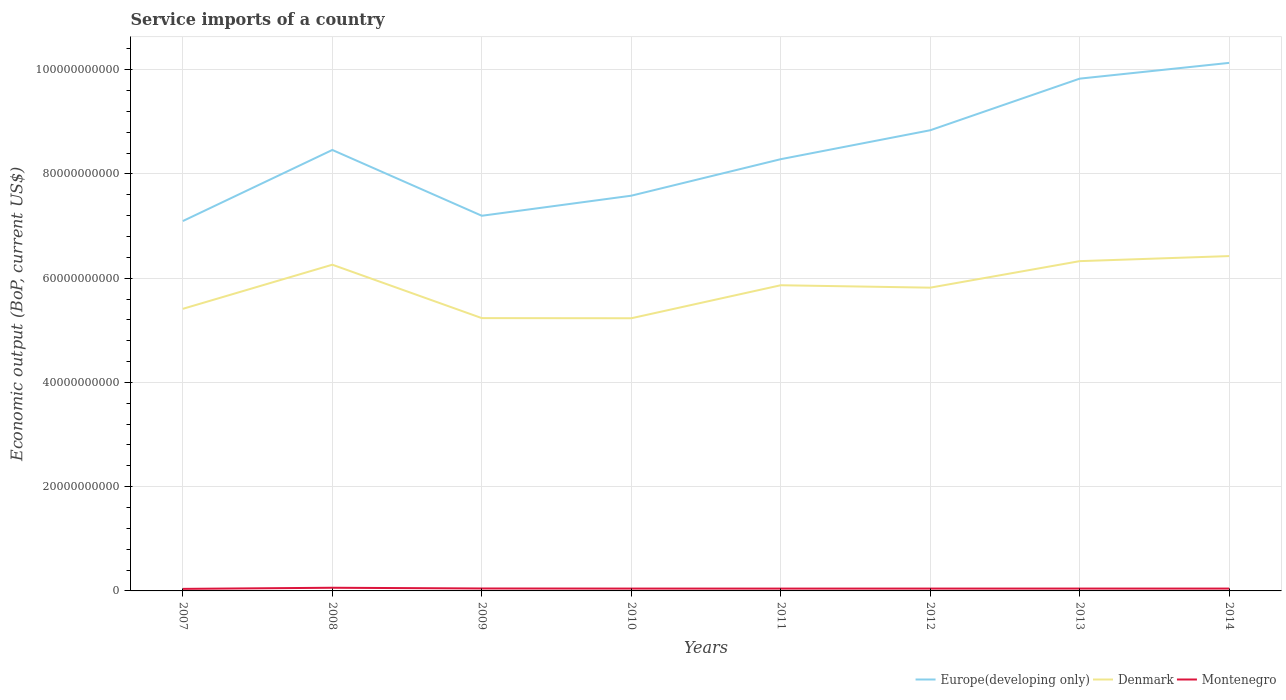How many different coloured lines are there?
Your answer should be very brief. 3. Across all years, what is the maximum service imports in Denmark?
Your answer should be very brief. 5.23e+1. What is the total service imports in Europe(developing only) in the graph?
Ensure brevity in your answer.  -1.19e+1. What is the difference between the highest and the second highest service imports in Montenegro?
Provide a short and direct response. 2.15e+08. What is the difference between the highest and the lowest service imports in Denmark?
Keep it short and to the point. 4. Are the values on the major ticks of Y-axis written in scientific E-notation?
Provide a succinct answer. No. Where does the legend appear in the graph?
Ensure brevity in your answer.  Bottom right. How many legend labels are there?
Keep it short and to the point. 3. How are the legend labels stacked?
Your answer should be very brief. Horizontal. What is the title of the graph?
Your response must be concise. Service imports of a country. What is the label or title of the X-axis?
Give a very brief answer. Years. What is the label or title of the Y-axis?
Ensure brevity in your answer.  Economic output (BoP, current US$). What is the Economic output (BoP, current US$) in Europe(developing only) in 2007?
Your answer should be very brief. 7.10e+1. What is the Economic output (BoP, current US$) in Denmark in 2007?
Make the answer very short. 5.41e+1. What is the Economic output (BoP, current US$) in Montenegro in 2007?
Offer a very short reply. 3.94e+08. What is the Economic output (BoP, current US$) in Europe(developing only) in 2008?
Give a very brief answer. 8.46e+1. What is the Economic output (BoP, current US$) of Denmark in 2008?
Your answer should be very brief. 6.26e+1. What is the Economic output (BoP, current US$) of Montenegro in 2008?
Keep it short and to the point. 6.09e+08. What is the Economic output (BoP, current US$) of Europe(developing only) in 2009?
Your answer should be compact. 7.20e+1. What is the Economic output (BoP, current US$) in Denmark in 2009?
Keep it short and to the point. 5.23e+1. What is the Economic output (BoP, current US$) of Montenegro in 2009?
Provide a short and direct response. 4.67e+08. What is the Economic output (BoP, current US$) in Europe(developing only) in 2010?
Offer a terse response. 7.58e+1. What is the Economic output (BoP, current US$) in Denmark in 2010?
Your response must be concise. 5.23e+1. What is the Economic output (BoP, current US$) of Montenegro in 2010?
Your answer should be compact. 4.51e+08. What is the Economic output (BoP, current US$) in Europe(developing only) in 2011?
Provide a short and direct response. 8.28e+1. What is the Economic output (BoP, current US$) in Denmark in 2011?
Provide a succinct answer. 5.86e+1. What is the Economic output (BoP, current US$) in Montenegro in 2011?
Ensure brevity in your answer.  4.48e+08. What is the Economic output (BoP, current US$) of Europe(developing only) in 2012?
Your response must be concise. 8.84e+1. What is the Economic output (BoP, current US$) in Denmark in 2012?
Your response must be concise. 5.82e+1. What is the Economic output (BoP, current US$) in Montenegro in 2012?
Ensure brevity in your answer.  4.49e+08. What is the Economic output (BoP, current US$) in Europe(developing only) in 2013?
Make the answer very short. 9.83e+1. What is the Economic output (BoP, current US$) in Denmark in 2013?
Keep it short and to the point. 6.33e+1. What is the Economic output (BoP, current US$) in Montenegro in 2013?
Make the answer very short. 4.53e+08. What is the Economic output (BoP, current US$) of Europe(developing only) in 2014?
Give a very brief answer. 1.01e+11. What is the Economic output (BoP, current US$) of Denmark in 2014?
Offer a very short reply. 6.42e+1. What is the Economic output (BoP, current US$) in Montenegro in 2014?
Offer a very short reply. 4.51e+08. Across all years, what is the maximum Economic output (BoP, current US$) of Europe(developing only)?
Keep it short and to the point. 1.01e+11. Across all years, what is the maximum Economic output (BoP, current US$) of Denmark?
Offer a terse response. 6.42e+1. Across all years, what is the maximum Economic output (BoP, current US$) of Montenegro?
Provide a succinct answer. 6.09e+08. Across all years, what is the minimum Economic output (BoP, current US$) of Europe(developing only)?
Your answer should be very brief. 7.10e+1. Across all years, what is the minimum Economic output (BoP, current US$) in Denmark?
Your response must be concise. 5.23e+1. Across all years, what is the minimum Economic output (BoP, current US$) in Montenegro?
Provide a succinct answer. 3.94e+08. What is the total Economic output (BoP, current US$) of Europe(developing only) in the graph?
Offer a very short reply. 6.74e+11. What is the total Economic output (BoP, current US$) of Denmark in the graph?
Offer a terse response. 4.66e+11. What is the total Economic output (BoP, current US$) of Montenegro in the graph?
Provide a succinct answer. 3.72e+09. What is the difference between the Economic output (BoP, current US$) in Europe(developing only) in 2007 and that in 2008?
Make the answer very short. -1.36e+1. What is the difference between the Economic output (BoP, current US$) in Denmark in 2007 and that in 2008?
Ensure brevity in your answer.  -8.46e+09. What is the difference between the Economic output (BoP, current US$) in Montenegro in 2007 and that in 2008?
Give a very brief answer. -2.15e+08. What is the difference between the Economic output (BoP, current US$) in Europe(developing only) in 2007 and that in 2009?
Give a very brief answer. -1.01e+09. What is the difference between the Economic output (BoP, current US$) in Denmark in 2007 and that in 2009?
Ensure brevity in your answer.  1.78e+09. What is the difference between the Economic output (BoP, current US$) in Montenegro in 2007 and that in 2009?
Provide a short and direct response. -7.32e+07. What is the difference between the Economic output (BoP, current US$) in Europe(developing only) in 2007 and that in 2010?
Provide a succinct answer. -4.86e+09. What is the difference between the Economic output (BoP, current US$) of Denmark in 2007 and that in 2010?
Your answer should be compact. 1.81e+09. What is the difference between the Economic output (BoP, current US$) of Montenegro in 2007 and that in 2010?
Offer a very short reply. -5.69e+07. What is the difference between the Economic output (BoP, current US$) in Europe(developing only) in 2007 and that in 2011?
Make the answer very short. -1.19e+1. What is the difference between the Economic output (BoP, current US$) in Denmark in 2007 and that in 2011?
Give a very brief answer. -4.52e+09. What is the difference between the Economic output (BoP, current US$) of Montenegro in 2007 and that in 2011?
Ensure brevity in your answer.  -5.38e+07. What is the difference between the Economic output (BoP, current US$) in Europe(developing only) in 2007 and that in 2012?
Keep it short and to the point. -1.74e+1. What is the difference between the Economic output (BoP, current US$) of Denmark in 2007 and that in 2012?
Your answer should be very brief. -4.06e+09. What is the difference between the Economic output (BoP, current US$) in Montenegro in 2007 and that in 2012?
Offer a terse response. -5.52e+07. What is the difference between the Economic output (BoP, current US$) in Europe(developing only) in 2007 and that in 2013?
Your answer should be compact. -2.73e+1. What is the difference between the Economic output (BoP, current US$) in Denmark in 2007 and that in 2013?
Give a very brief answer. -9.15e+09. What is the difference between the Economic output (BoP, current US$) of Montenegro in 2007 and that in 2013?
Your response must be concise. -5.95e+07. What is the difference between the Economic output (BoP, current US$) of Europe(developing only) in 2007 and that in 2014?
Offer a terse response. -3.03e+1. What is the difference between the Economic output (BoP, current US$) in Denmark in 2007 and that in 2014?
Offer a very short reply. -1.01e+1. What is the difference between the Economic output (BoP, current US$) of Montenegro in 2007 and that in 2014?
Your answer should be compact. -5.68e+07. What is the difference between the Economic output (BoP, current US$) in Europe(developing only) in 2008 and that in 2009?
Provide a succinct answer. 1.26e+1. What is the difference between the Economic output (BoP, current US$) in Denmark in 2008 and that in 2009?
Make the answer very short. 1.02e+1. What is the difference between the Economic output (BoP, current US$) of Montenegro in 2008 and that in 2009?
Your response must be concise. 1.42e+08. What is the difference between the Economic output (BoP, current US$) in Europe(developing only) in 2008 and that in 2010?
Ensure brevity in your answer.  8.77e+09. What is the difference between the Economic output (BoP, current US$) in Denmark in 2008 and that in 2010?
Give a very brief answer. 1.03e+1. What is the difference between the Economic output (BoP, current US$) in Montenegro in 2008 and that in 2010?
Your answer should be compact. 1.58e+08. What is the difference between the Economic output (BoP, current US$) of Europe(developing only) in 2008 and that in 2011?
Give a very brief answer. 1.77e+09. What is the difference between the Economic output (BoP, current US$) in Denmark in 2008 and that in 2011?
Make the answer very short. 3.94e+09. What is the difference between the Economic output (BoP, current US$) in Montenegro in 2008 and that in 2011?
Offer a very short reply. 1.61e+08. What is the difference between the Economic output (BoP, current US$) of Europe(developing only) in 2008 and that in 2012?
Keep it short and to the point. -3.78e+09. What is the difference between the Economic output (BoP, current US$) of Denmark in 2008 and that in 2012?
Give a very brief answer. 4.40e+09. What is the difference between the Economic output (BoP, current US$) in Montenegro in 2008 and that in 2012?
Ensure brevity in your answer.  1.60e+08. What is the difference between the Economic output (BoP, current US$) in Europe(developing only) in 2008 and that in 2013?
Your response must be concise. -1.37e+1. What is the difference between the Economic output (BoP, current US$) of Denmark in 2008 and that in 2013?
Provide a succinct answer. -6.86e+08. What is the difference between the Economic output (BoP, current US$) in Montenegro in 2008 and that in 2013?
Offer a terse response. 1.56e+08. What is the difference between the Economic output (BoP, current US$) of Europe(developing only) in 2008 and that in 2014?
Give a very brief answer. -1.67e+1. What is the difference between the Economic output (BoP, current US$) in Denmark in 2008 and that in 2014?
Make the answer very short. -1.66e+09. What is the difference between the Economic output (BoP, current US$) of Montenegro in 2008 and that in 2014?
Ensure brevity in your answer.  1.58e+08. What is the difference between the Economic output (BoP, current US$) of Europe(developing only) in 2009 and that in 2010?
Your response must be concise. -3.85e+09. What is the difference between the Economic output (BoP, current US$) in Denmark in 2009 and that in 2010?
Your answer should be compact. 2.79e+07. What is the difference between the Economic output (BoP, current US$) in Montenegro in 2009 and that in 2010?
Provide a short and direct response. 1.63e+07. What is the difference between the Economic output (BoP, current US$) of Europe(developing only) in 2009 and that in 2011?
Your answer should be compact. -1.09e+1. What is the difference between the Economic output (BoP, current US$) of Denmark in 2009 and that in 2011?
Make the answer very short. -6.30e+09. What is the difference between the Economic output (BoP, current US$) in Montenegro in 2009 and that in 2011?
Your answer should be compact. 1.94e+07. What is the difference between the Economic output (BoP, current US$) in Europe(developing only) in 2009 and that in 2012?
Your answer should be very brief. -1.64e+1. What is the difference between the Economic output (BoP, current US$) of Denmark in 2009 and that in 2012?
Offer a terse response. -5.84e+09. What is the difference between the Economic output (BoP, current US$) in Montenegro in 2009 and that in 2012?
Your answer should be compact. 1.80e+07. What is the difference between the Economic output (BoP, current US$) in Europe(developing only) in 2009 and that in 2013?
Your answer should be compact. -2.63e+1. What is the difference between the Economic output (BoP, current US$) in Denmark in 2009 and that in 2013?
Your answer should be compact. -1.09e+1. What is the difference between the Economic output (BoP, current US$) in Montenegro in 2009 and that in 2013?
Your answer should be compact. 1.38e+07. What is the difference between the Economic output (BoP, current US$) of Europe(developing only) in 2009 and that in 2014?
Make the answer very short. -2.93e+1. What is the difference between the Economic output (BoP, current US$) of Denmark in 2009 and that in 2014?
Make the answer very short. -1.19e+1. What is the difference between the Economic output (BoP, current US$) in Montenegro in 2009 and that in 2014?
Your answer should be compact. 1.64e+07. What is the difference between the Economic output (BoP, current US$) in Europe(developing only) in 2010 and that in 2011?
Give a very brief answer. -7.00e+09. What is the difference between the Economic output (BoP, current US$) in Denmark in 2010 and that in 2011?
Provide a succinct answer. -6.33e+09. What is the difference between the Economic output (BoP, current US$) of Montenegro in 2010 and that in 2011?
Your response must be concise. 3.09e+06. What is the difference between the Economic output (BoP, current US$) in Europe(developing only) in 2010 and that in 2012?
Provide a short and direct response. -1.26e+1. What is the difference between the Economic output (BoP, current US$) of Denmark in 2010 and that in 2012?
Give a very brief answer. -5.87e+09. What is the difference between the Economic output (BoP, current US$) of Montenegro in 2010 and that in 2012?
Keep it short and to the point. 1.73e+06. What is the difference between the Economic output (BoP, current US$) of Europe(developing only) in 2010 and that in 2013?
Provide a short and direct response. -2.25e+1. What is the difference between the Economic output (BoP, current US$) in Denmark in 2010 and that in 2013?
Offer a very short reply. -1.10e+1. What is the difference between the Economic output (BoP, current US$) of Montenegro in 2010 and that in 2013?
Give a very brief answer. -2.53e+06. What is the difference between the Economic output (BoP, current US$) of Europe(developing only) in 2010 and that in 2014?
Offer a very short reply. -2.55e+1. What is the difference between the Economic output (BoP, current US$) of Denmark in 2010 and that in 2014?
Give a very brief answer. -1.19e+1. What is the difference between the Economic output (BoP, current US$) of Montenegro in 2010 and that in 2014?
Give a very brief answer. 1.15e+05. What is the difference between the Economic output (BoP, current US$) of Europe(developing only) in 2011 and that in 2012?
Provide a short and direct response. -5.55e+09. What is the difference between the Economic output (BoP, current US$) of Denmark in 2011 and that in 2012?
Ensure brevity in your answer.  4.63e+08. What is the difference between the Economic output (BoP, current US$) in Montenegro in 2011 and that in 2012?
Offer a terse response. -1.36e+06. What is the difference between the Economic output (BoP, current US$) of Europe(developing only) in 2011 and that in 2013?
Offer a very short reply. -1.55e+1. What is the difference between the Economic output (BoP, current US$) of Denmark in 2011 and that in 2013?
Your answer should be very brief. -4.63e+09. What is the difference between the Economic output (BoP, current US$) in Montenegro in 2011 and that in 2013?
Keep it short and to the point. -5.62e+06. What is the difference between the Economic output (BoP, current US$) in Europe(developing only) in 2011 and that in 2014?
Provide a succinct answer. -1.85e+1. What is the difference between the Economic output (BoP, current US$) in Denmark in 2011 and that in 2014?
Offer a terse response. -5.60e+09. What is the difference between the Economic output (BoP, current US$) in Montenegro in 2011 and that in 2014?
Your answer should be very brief. -2.97e+06. What is the difference between the Economic output (BoP, current US$) in Europe(developing only) in 2012 and that in 2013?
Provide a short and direct response. -9.90e+09. What is the difference between the Economic output (BoP, current US$) in Denmark in 2012 and that in 2013?
Give a very brief answer. -5.09e+09. What is the difference between the Economic output (BoP, current US$) in Montenegro in 2012 and that in 2013?
Give a very brief answer. -4.26e+06. What is the difference between the Economic output (BoP, current US$) of Europe(developing only) in 2012 and that in 2014?
Provide a succinct answer. -1.29e+1. What is the difference between the Economic output (BoP, current US$) of Denmark in 2012 and that in 2014?
Make the answer very short. -6.06e+09. What is the difference between the Economic output (BoP, current US$) of Montenegro in 2012 and that in 2014?
Provide a succinct answer. -1.61e+06. What is the difference between the Economic output (BoP, current US$) of Europe(developing only) in 2013 and that in 2014?
Offer a terse response. -3.02e+09. What is the difference between the Economic output (BoP, current US$) of Denmark in 2013 and that in 2014?
Your answer should be very brief. -9.70e+08. What is the difference between the Economic output (BoP, current US$) of Montenegro in 2013 and that in 2014?
Provide a short and direct response. 2.65e+06. What is the difference between the Economic output (BoP, current US$) in Europe(developing only) in 2007 and the Economic output (BoP, current US$) in Denmark in 2008?
Offer a very short reply. 8.38e+09. What is the difference between the Economic output (BoP, current US$) in Europe(developing only) in 2007 and the Economic output (BoP, current US$) in Montenegro in 2008?
Make the answer very short. 7.04e+1. What is the difference between the Economic output (BoP, current US$) of Denmark in 2007 and the Economic output (BoP, current US$) of Montenegro in 2008?
Your response must be concise. 5.35e+1. What is the difference between the Economic output (BoP, current US$) of Europe(developing only) in 2007 and the Economic output (BoP, current US$) of Denmark in 2009?
Offer a terse response. 1.86e+1. What is the difference between the Economic output (BoP, current US$) in Europe(developing only) in 2007 and the Economic output (BoP, current US$) in Montenegro in 2009?
Ensure brevity in your answer.  7.05e+1. What is the difference between the Economic output (BoP, current US$) of Denmark in 2007 and the Economic output (BoP, current US$) of Montenegro in 2009?
Offer a very short reply. 5.37e+1. What is the difference between the Economic output (BoP, current US$) in Europe(developing only) in 2007 and the Economic output (BoP, current US$) in Denmark in 2010?
Your answer should be compact. 1.86e+1. What is the difference between the Economic output (BoP, current US$) in Europe(developing only) in 2007 and the Economic output (BoP, current US$) in Montenegro in 2010?
Make the answer very short. 7.05e+1. What is the difference between the Economic output (BoP, current US$) in Denmark in 2007 and the Economic output (BoP, current US$) in Montenegro in 2010?
Ensure brevity in your answer.  5.37e+1. What is the difference between the Economic output (BoP, current US$) of Europe(developing only) in 2007 and the Economic output (BoP, current US$) of Denmark in 2011?
Your answer should be compact. 1.23e+1. What is the difference between the Economic output (BoP, current US$) in Europe(developing only) in 2007 and the Economic output (BoP, current US$) in Montenegro in 2011?
Keep it short and to the point. 7.05e+1. What is the difference between the Economic output (BoP, current US$) in Denmark in 2007 and the Economic output (BoP, current US$) in Montenegro in 2011?
Keep it short and to the point. 5.37e+1. What is the difference between the Economic output (BoP, current US$) of Europe(developing only) in 2007 and the Economic output (BoP, current US$) of Denmark in 2012?
Provide a short and direct response. 1.28e+1. What is the difference between the Economic output (BoP, current US$) in Europe(developing only) in 2007 and the Economic output (BoP, current US$) in Montenegro in 2012?
Offer a terse response. 7.05e+1. What is the difference between the Economic output (BoP, current US$) in Denmark in 2007 and the Economic output (BoP, current US$) in Montenegro in 2012?
Offer a terse response. 5.37e+1. What is the difference between the Economic output (BoP, current US$) of Europe(developing only) in 2007 and the Economic output (BoP, current US$) of Denmark in 2013?
Provide a short and direct response. 7.69e+09. What is the difference between the Economic output (BoP, current US$) in Europe(developing only) in 2007 and the Economic output (BoP, current US$) in Montenegro in 2013?
Offer a very short reply. 7.05e+1. What is the difference between the Economic output (BoP, current US$) of Denmark in 2007 and the Economic output (BoP, current US$) of Montenegro in 2013?
Your answer should be very brief. 5.37e+1. What is the difference between the Economic output (BoP, current US$) of Europe(developing only) in 2007 and the Economic output (BoP, current US$) of Denmark in 2014?
Offer a terse response. 6.72e+09. What is the difference between the Economic output (BoP, current US$) of Europe(developing only) in 2007 and the Economic output (BoP, current US$) of Montenegro in 2014?
Your answer should be very brief. 7.05e+1. What is the difference between the Economic output (BoP, current US$) in Denmark in 2007 and the Economic output (BoP, current US$) in Montenegro in 2014?
Offer a terse response. 5.37e+1. What is the difference between the Economic output (BoP, current US$) of Europe(developing only) in 2008 and the Economic output (BoP, current US$) of Denmark in 2009?
Give a very brief answer. 3.23e+1. What is the difference between the Economic output (BoP, current US$) of Europe(developing only) in 2008 and the Economic output (BoP, current US$) of Montenegro in 2009?
Your answer should be compact. 8.41e+1. What is the difference between the Economic output (BoP, current US$) of Denmark in 2008 and the Economic output (BoP, current US$) of Montenegro in 2009?
Keep it short and to the point. 6.21e+1. What is the difference between the Economic output (BoP, current US$) of Europe(developing only) in 2008 and the Economic output (BoP, current US$) of Denmark in 2010?
Your response must be concise. 3.23e+1. What is the difference between the Economic output (BoP, current US$) of Europe(developing only) in 2008 and the Economic output (BoP, current US$) of Montenegro in 2010?
Provide a short and direct response. 8.41e+1. What is the difference between the Economic output (BoP, current US$) of Denmark in 2008 and the Economic output (BoP, current US$) of Montenegro in 2010?
Keep it short and to the point. 6.21e+1. What is the difference between the Economic output (BoP, current US$) in Europe(developing only) in 2008 and the Economic output (BoP, current US$) in Denmark in 2011?
Provide a succinct answer. 2.60e+1. What is the difference between the Economic output (BoP, current US$) in Europe(developing only) in 2008 and the Economic output (BoP, current US$) in Montenegro in 2011?
Provide a short and direct response. 8.42e+1. What is the difference between the Economic output (BoP, current US$) of Denmark in 2008 and the Economic output (BoP, current US$) of Montenegro in 2011?
Make the answer very short. 6.21e+1. What is the difference between the Economic output (BoP, current US$) of Europe(developing only) in 2008 and the Economic output (BoP, current US$) of Denmark in 2012?
Your answer should be very brief. 2.64e+1. What is the difference between the Economic output (BoP, current US$) in Europe(developing only) in 2008 and the Economic output (BoP, current US$) in Montenegro in 2012?
Your response must be concise. 8.41e+1. What is the difference between the Economic output (BoP, current US$) in Denmark in 2008 and the Economic output (BoP, current US$) in Montenegro in 2012?
Provide a succinct answer. 6.21e+1. What is the difference between the Economic output (BoP, current US$) in Europe(developing only) in 2008 and the Economic output (BoP, current US$) in Denmark in 2013?
Offer a terse response. 2.13e+1. What is the difference between the Economic output (BoP, current US$) in Europe(developing only) in 2008 and the Economic output (BoP, current US$) in Montenegro in 2013?
Make the answer very short. 8.41e+1. What is the difference between the Economic output (BoP, current US$) of Denmark in 2008 and the Economic output (BoP, current US$) of Montenegro in 2013?
Provide a succinct answer. 6.21e+1. What is the difference between the Economic output (BoP, current US$) in Europe(developing only) in 2008 and the Economic output (BoP, current US$) in Denmark in 2014?
Keep it short and to the point. 2.04e+1. What is the difference between the Economic output (BoP, current US$) in Europe(developing only) in 2008 and the Economic output (BoP, current US$) in Montenegro in 2014?
Your answer should be compact. 8.41e+1. What is the difference between the Economic output (BoP, current US$) of Denmark in 2008 and the Economic output (BoP, current US$) of Montenegro in 2014?
Your answer should be compact. 6.21e+1. What is the difference between the Economic output (BoP, current US$) in Europe(developing only) in 2009 and the Economic output (BoP, current US$) in Denmark in 2010?
Your answer should be very brief. 1.97e+1. What is the difference between the Economic output (BoP, current US$) of Europe(developing only) in 2009 and the Economic output (BoP, current US$) of Montenegro in 2010?
Keep it short and to the point. 7.15e+1. What is the difference between the Economic output (BoP, current US$) of Denmark in 2009 and the Economic output (BoP, current US$) of Montenegro in 2010?
Give a very brief answer. 5.19e+1. What is the difference between the Economic output (BoP, current US$) of Europe(developing only) in 2009 and the Economic output (BoP, current US$) of Denmark in 2011?
Your answer should be very brief. 1.33e+1. What is the difference between the Economic output (BoP, current US$) in Europe(developing only) in 2009 and the Economic output (BoP, current US$) in Montenegro in 2011?
Your answer should be very brief. 7.15e+1. What is the difference between the Economic output (BoP, current US$) in Denmark in 2009 and the Economic output (BoP, current US$) in Montenegro in 2011?
Give a very brief answer. 5.19e+1. What is the difference between the Economic output (BoP, current US$) in Europe(developing only) in 2009 and the Economic output (BoP, current US$) in Denmark in 2012?
Your answer should be very brief. 1.38e+1. What is the difference between the Economic output (BoP, current US$) of Europe(developing only) in 2009 and the Economic output (BoP, current US$) of Montenegro in 2012?
Provide a succinct answer. 7.15e+1. What is the difference between the Economic output (BoP, current US$) in Denmark in 2009 and the Economic output (BoP, current US$) in Montenegro in 2012?
Your answer should be compact. 5.19e+1. What is the difference between the Economic output (BoP, current US$) of Europe(developing only) in 2009 and the Economic output (BoP, current US$) of Denmark in 2013?
Offer a terse response. 8.71e+09. What is the difference between the Economic output (BoP, current US$) of Europe(developing only) in 2009 and the Economic output (BoP, current US$) of Montenegro in 2013?
Offer a terse response. 7.15e+1. What is the difference between the Economic output (BoP, current US$) in Denmark in 2009 and the Economic output (BoP, current US$) in Montenegro in 2013?
Your answer should be compact. 5.19e+1. What is the difference between the Economic output (BoP, current US$) in Europe(developing only) in 2009 and the Economic output (BoP, current US$) in Denmark in 2014?
Your answer should be very brief. 7.74e+09. What is the difference between the Economic output (BoP, current US$) of Europe(developing only) in 2009 and the Economic output (BoP, current US$) of Montenegro in 2014?
Your response must be concise. 7.15e+1. What is the difference between the Economic output (BoP, current US$) of Denmark in 2009 and the Economic output (BoP, current US$) of Montenegro in 2014?
Offer a terse response. 5.19e+1. What is the difference between the Economic output (BoP, current US$) of Europe(developing only) in 2010 and the Economic output (BoP, current US$) of Denmark in 2011?
Keep it short and to the point. 1.72e+1. What is the difference between the Economic output (BoP, current US$) of Europe(developing only) in 2010 and the Economic output (BoP, current US$) of Montenegro in 2011?
Your answer should be compact. 7.54e+1. What is the difference between the Economic output (BoP, current US$) in Denmark in 2010 and the Economic output (BoP, current US$) in Montenegro in 2011?
Offer a terse response. 5.19e+1. What is the difference between the Economic output (BoP, current US$) in Europe(developing only) in 2010 and the Economic output (BoP, current US$) in Denmark in 2012?
Offer a terse response. 1.76e+1. What is the difference between the Economic output (BoP, current US$) in Europe(developing only) in 2010 and the Economic output (BoP, current US$) in Montenegro in 2012?
Make the answer very short. 7.54e+1. What is the difference between the Economic output (BoP, current US$) of Denmark in 2010 and the Economic output (BoP, current US$) of Montenegro in 2012?
Your answer should be very brief. 5.19e+1. What is the difference between the Economic output (BoP, current US$) in Europe(developing only) in 2010 and the Economic output (BoP, current US$) in Denmark in 2013?
Keep it short and to the point. 1.26e+1. What is the difference between the Economic output (BoP, current US$) of Europe(developing only) in 2010 and the Economic output (BoP, current US$) of Montenegro in 2013?
Offer a terse response. 7.54e+1. What is the difference between the Economic output (BoP, current US$) in Denmark in 2010 and the Economic output (BoP, current US$) in Montenegro in 2013?
Ensure brevity in your answer.  5.19e+1. What is the difference between the Economic output (BoP, current US$) in Europe(developing only) in 2010 and the Economic output (BoP, current US$) in Denmark in 2014?
Keep it short and to the point. 1.16e+1. What is the difference between the Economic output (BoP, current US$) of Europe(developing only) in 2010 and the Economic output (BoP, current US$) of Montenegro in 2014?
Keep it short and to the point. 7.54e+1. What is the difference between the Economic output (BoP, current US$) in Denmark in 2010 and the Economic output (BoP, current US$) in Montenegro in 2014?
Keep it short and to the point. 5.19e+1. What is the difference between the Economic output (BoP, current US$) in Europe(developing only) in 2011 and the Economic output (BoP, current US$) in Denmark in 2012?
Ensure brevity in your answer.  2.46e+1. What is the difference between the Economic output (BoP, current US$) in Europe(developing only) in 2011 and the Economic output (BoP, current US$) in Montenegro in 2012?
Your answer should be very brief. 8.24e+1. What is the difference between the Economic output (BoP, current US$) in Denmark in 2011 and the Economic output (BoP, current US$) in Montenegro in 2012?
Your answer should be compact. 5.82e+1. What is the difference between the Economic output (BoP, current US$) of Europe(developing only) in 2011 and the Economic output (BoP, current US$) of Denmark in 2013?
Make the answer very short. 1.96e+1. What is the difference between the Economic output (BoP, current US$) in Europe(developing only) in 2011 and the Economic output (BoP, current US$) in Montenegro in 2013?
Provide a succinct answer. 8.24e+1. What is the difference between the Economic output (BoP, current US$) in Denmark in 2011 and the Economic output (BoP, current US$) in Montenegro in 2013?
Keep it short and to the point. 5.82e+1. What is the difference between the Economic output (BoP, current US$) of Europe(developing only) in 2011 and the Economic output (BoP, current US$) of Denmark in 2014?
Your answer should be very brief. 1.86e+1. What is the difference between the Economic output (BoP, current US$) of Europe(developing only) in 2011 and the Economic output (BoP, current US$) of Montenegro in 2014?
Provide a succinct answer. 8.24e+1. What is the difference between the Economic output (BoP, current US$) in Denmark in 2011 and the Economic output (BoP, current US$) in Montenegro in 2014?
Your response must be concise. 5.82e+1. What is the difference between the Economic output (BoP, current US$) in Europe(developing only) in 2012 and the Economic output (BoP, current US$) in Denmark in 2013?
Keep it short and to the point. 2.51e+1. What is the difference between the Economic output (BoP, current US$) in Europe(developing only) in 2012 and the Economic output (BoP, current US$) in Montenegro in 2013?
Give a very brief answer. 8.79e+1. What is the difference between the Economic output (BoP, current US$) of Denmark in 2012 and the Economic output (BoP, current US$) of Montenegro in 2013?
Offer a very short reply. 5.77e+1. What is the difference between the Economic output (BoP, current US$) of Europe(developing only) in 2012 and the Economic output (BoP, current US$) of Denmark in 2014?
Provide a succinct answer. 2.41e+1. What is the difference between the Economic output (BoP, current US$) in Europe(developing only) in 2012 and the Economic output (BoP, current US$) in Montenegro in 2014?
Your answer should be compact. 8.79e+1. What is the difference between the Economic output (BoP, current US$) in Denmark in 2012 and the Economic output (BoP, current US$) in Montenegro in 2014?
Provide a short and direct response. 5.77e+1. What is the difference between the Economic output (BoP, current US$) of Europe(developing only) in 2013 and the Economic output (BoP, current US$) of Denmark in 2014?
Your answer should be compact. 3.40e+1. What is the difference between the Economic output (BoP, current US$) of Europe(developing only) in 2013 and the Economic output (BoP, current US$) of Montenegro in 2014?
Offer a terse response. 9.78e+1. What is the difference between the Economic output (BoP, current US$) in Denmark in 2013 and the Economic output (BoP, current US$) in Montenegro in 2014?
Make the answer very short. 6.28e+1. What is the average Economic output (BoP, current US$) in Europe(developing only) per year?
Provide a short and direct response. 8.43e+1. What is the average Economic output (BoP, current US$) in Denmark per year?
Offer a terse response. 5.82e+1. What is the average Economic output (BoP, current US$) in Montenegro per year?
Offer a very short reply. 4.65e+08. In the year 2007, what is the difference between the Economic output (BoP, current US$) in Europe(developing only) and Economic output (BoP, current US$) in Denmark?
Provide a short and direct response. 1.68e+1. In the year 2007, what is the difference between the Economic output (BoP, current US$) of Europe(developing only) and Economic output (BoP, current US$) of Montenegro?
Provide a short and direct response. 7.06e+1. In the year 2007, what is the difference between the Economic output (BoP, current US$) of Denmark and Economic output (BoP, current US$) of Montenegro?
Keep it short and to the point. 5.37e+1. In the year 2008, what is the difference between the Economic output (BoP, current US$) of Europe(developing only) and Economic output (BoP, current US$) of Denmark?
Give a very brief answer. 2.20e+1. In the year 2008, what is the difference between the Economic output (BoP, current US$) of Europe(developing only) and Economic output (BoP, current US$) of Montenegro?
Your response must be concise. 8.40e+1. In the year 2008, what is the difference between the Economic output (BoP, current US$) of Denmark and Economic output (BoP, current US$) of Montenegro?
Give a very brief answer. 6.20e+1. In the year 2009, what is the difference between the Economic output (BoP, current US$) in Europe(developing only) and Economic output (BoP, current US$) in Denmark?
Keep it short and to the point. 1.96e+1. In the year 2009, what is the difference between the Economic output (BoP, current US$) of Europe(developing only) and Economic output (BoP, current US$) of Montenegro?
Your answer should be compact. 7.15e+1. In the year 2009, what is the difference between the Economic output (BoP, current US$) in Denmark and Economic output (BoP, current US$) in Montenegro?
Give a very brief answer. 5.19e+1. In the year 2010, what is the difference between the Economic output (BoP, current US$) in Europe(developing only) and Economic output (BoP, current US$) in Denmark?
Offer a very short reply. 2.35e+1. In the year 2010, what is the difference between the Economic output (BoP, current US$) of Europe(developing only) and Economic output (BoP, current US$) of Montenegro?
Give a very brief answer. 7.54e+1. In the year 2010, what is the difference between the Economic output (BoP, current US$) of Denmark and Economic output (BoP, current US$) of Montenegro?
Your answer should be very brief. 5.19e+1. In the year 2011, what is the difference between the Economic output (BoP, current US$) of Europe(developing only) and Economic output (BoP, current US$) of Denmark?
Keep it short and to the point. 2.42e+1. In the year 2011, what is the difference between the Economic output (BoP, current US$) of Europe(developing only) and Economic output (BoP, current US$) of Montenegro?
Ensure brevity in your answer.  8.24e+1. In the year 2011, what is the difference between the Economic output (BoP, current US$) in Denmark and Economic output (BoP, current US$) in Montenegro?
Your answer should be compact. 5.82e+1. In the year 2012, what is the difference between the Economic output (BoP, current US$) in Europe(developing only) and Economic output (BoP, current US$) in Denmark?
Keep it short and to the point. 3.02e+1. In the year 2012, what is the difference between the Economic output (BoP, current US$) of Europe(developing only) and Economic output (BoP, current US$) of Montenegro?
Ensure brevity in your answer.  8.79e+1. In the year 2012, what is the difference between the Economic output (BoP, current US$) in Denmark and Economic output (BoP, current US$) in Montenegro?
Your answer should be compact. 5.77e+1. In the year 2013, what is the difference between the Economic output (BoP, current US$) of Europe(developing only) and Economic output (BoP, current US$) of Denmark?
Your answer should be compact. 3.50e+1. In the year 2013, what is the difference between the Economic output (BoP, current US$) of Europe(developing only) and Economic output (BoP, current US$) of Montenegro?
Your response must be concise. 9.78e+1. In the year 2013, what is the difference between the Economic output (BoP, current US$) of Denmark and Economic output (BoP, current US$) of Montenegro?
Offer a very short reply. 6.28e+1. In the year 2014, what is the difference between the Economic output (BoP, current US$) of Europe(developing only) and Economic output (BoP, current US$) of Denmark?
Give a very brief answer. 3.71e+1. In the year 2014, what is the difference between the Economic output (BoP, current US$) of Europe(developing only) and Economic output (BoP, current US$) of Montenegro?
Provide a succinct answer. 1.01e+11. In the year 2014, what is the difference between the Economic output (BoP, current US$) in Denmark and Economic output (BoP, current US$) in Montenegro?
Your response must be concise. 6.38e+1. What is the ratio of the Economic output (BoP, current US$) in Europe(developing only) in 2007 to that in 2008?
Keep it short and to the point. 0.84. What is the ratio of the Economic output (BoP, current US$) in Denmark in 2007 to that in 2008?
Provide a succinct answer. 0.86. What is the ratio of the Economic output (BoP, current US$) in Montenegro in 2007 to that in 2008?
Provide a short and direct response. 0.65. What is the ratio of the Economic output (BoP, current US$) of Europe(developing only) in 2007 to that in 2009?
Make the answer very short. 0.99. What is the ratio of the Economic output (BoP, current US$) of Denmark in 2007 to that in 2009?
Offer a terse response. 1.03. What is the ratio of the Economic output (BoP, current US$) in Montenegro in 2007 to that in 2009?
Provide a short and direct response. 0.84. What is the ratio of the Economic output (BoP, current US$) of Europe(developing only) in 2007 to that in 2010?
Give a very brief answer. 0.94. What is the ratio of the Economic output (BoP, current US$) of Denmark in 2007 to that in 2010?
Provide a succinct answer. 1.03. What is the ratio of the Economic output (BoP, current US$) in Montenegro in 2007 to that in 2010?
Ensure brevity in your answer.  0.87. What is the ratio of the Economic output (BoP, current US$) of Europe(developing only) in 2007 to that in 2011?
Offer a terse response. 0.86. What is the ratio of the Economic output (BoP, current US$) of Denmark in 2007 to that in 2011?
Provide a short and direct response. 0.92. What is the ratio of the Economic output (BoP, current US$) of Montenegro in 2007 to that in 2011?
Make the answer very short. 0.88. What is the ratio of the Economic output (BoP, current US$) in Europe(developing only) in 2007 to that in 2012?
Your answer should be compact. 0.8. What is the ratio of the Economic output (BoP, current US$) in Denmark in 2007 to that in 2012?
Your answer should be compact. 0.93. What is the ratio of the Economic output (BoP, current US$) of Montenegro in 2007 to that in 2012?
Your answer should be compact. 0.88. What is the ratio of the Economic output (BoP, current US$) in Europe(developing only) in 2007 to that in 2013?
Give a very brief answer. 0.72. What is the ratio of the Economic output (BoP, current US$) in Denmark in 2007 to that in 2013?
Offer a very short reply. 0.86. What is the ratio of the Economic output (BoP, current US$) of Montenegro in 2007 to that in 2013?
Your answer should be compact. 0.87. What is the ratio of the Economic output (BoP, current US$) in Europe(developing only) in 2007 to that in 2014?
Your answer should be very brief. 0.7. What is the ratio of the Economic output (BoP, current US$) in Denmark in 2007 to that in 2014?
Make the answer very short. 0.84. What is the ratio of the Economic output (BoP, current US$) in Montenegro in 2007 to that in 2014?
Your response must be concise. 0.87. What is the ratio of the Economic output (BoP, current US$) in Europe(developing only) in 2008 to that in 2009?
Your response must be concise. 1.18. What is the ratio of the Economic output (BoP, current US$) of Denmark in 2008 to that in 2009?
Provide a succinct answer. 1.2. What is the ratio of the Economic output (BoP, current US$) in Montenegro in 2008 to that in 2009?
Your answer should be compact. 1.3. What is the ratio of the Economic output (BoP, current US$) in Europe(developing only) in 2008 to that in 2010?
Your answer should be very brief. 1.12. What is the ratio of the Economic output (BoP, current US$) of Denmark in 2008 to that in 2010?
Provide a short and direct response. 1.2. What is the ratio of the Economic output (BoP, current US$) in Montenegro in 2008 to that in 2010?
Provide a short and direct response. 1.35. What is the ratio of the Economic output (BoP, current US$) of Europe(developing only) in 2008 to that in 2011?
Your answer should be very brief. 1.02. What is the ratio of the Economic output (BoP, current US$) in Denmark in 2008 to that in 2011?
Provide a succinct answer. 1.07. What is the ratio of the Economic output (BoP, current US$) in Montenegro in 2008 to that in 2011?
Provide a short and direct response. 1.36. What is the ratio of the Economic output (BoP, current US$) in Europe(developing only) in 2008 to that in 2012?
Keep it short and to the point. 0.96. What is the ratio of the Economic output (BoP, current US$) in Denmark in 2008 to that in 2012?
Make the answer very short. 1.08. What is the ratio of the Economic output (BoP, current US$) in Montenegro in 2008 to that in 2012?
Make the answer very short. 1.36. What is the ratio of the Economic output (BoP, current US$) in Europe(developing only) in 2008 to that in 2013?
Keep it short and to the point. 0.86. What is the ratio of the Economic output (BoP, current US$) in Montenegro in 2008 to that in 2013?
Offer a very short reply. 1.34. What is the ratio of the Economic output (BoP, current US$) in Europe(developing only) in 2008 to that in 2014?
Your response must be concise. 0.84. What is the ratio of the Economic output (BoP, current US$) in Denmark in 2008 to that in 2014?
Your response must be concise. 0.97. What is the ratio of the Economic output (BoP, current US$) in Montenegro in 2008 to that in 2014?
Provide a short and direct response. 1.35. What is the ratio of the Economic output (BoP, current US$) in Europe(developing only) in 2009 to that in 2010?
Your answer should be compact. 0.95. What is the ratio of the Economic output (BoP, current US$) of Montenegro in 2009 to that in 2010?
Ensure brevity in your answer.  1.04. What is the ratio of the Economic output (BoP, current US$) of Europe(developing only) in 2009 to that in 2011?
Give a very brief answer. 0.87. What is the ratio of the Economic output (BoP, current US$) in Denmark in 2009 to that in 2011?
Ensure brevity in your answer.  0.89. What is the ratio of the Economic output (BoP, current US$) of Montenegro in 2009 to that in 2011?
Ensure brevity in your answer.  1.04. What is the ratio of the Economic output (BoP, current US$) in Europe(developing only) in 2009 to that in 2012?
Provide a short and direct response. 0.81. What is the ratio of the Economic output (BoP, current US$) in Denmark in 2009 to that in 2012?
Make the answer very short. 0.9. What is the ratio of the Economic output (BoP, current US$) in Montenegro in 2009 to that in 2012?
Offer a very short reply. 1.04. What is the ratio of the Economic output (BoP, current US$) of Europe(developing only) in 2009 to that in 2013?
Provide a short and direct response. 0.73. What is the ratio of the Economic output (BoP, current US$) in Denmark in 2009 to that in 2013?
Keep it short and to the point. 0.83. What is the ratio of the Economic output (BoP, current US$) in Montenegro in 2009 to that in 2013?
Give a very brief answer. 1.03. What is the ratio of the Economic output (BoP, current US$) of Europe(developing only) in 2009 to that in 2014?
Give a very brief answer. 0.71. What is the ratio of the Economic output (BoP, current US$) in Denmark in 2009 to that in 2014?
Give a very brief answer. 0.81. What is the ratio of the Economic output (BoP, current US$) in Montenegro in 2009 to that in 2014?
Provide a succinct answer. 1.04. What is the ratio of the Economic output (BoP, current US$) in Europe(developing only) in 2010 to that in 2011?
Your answer should be compact. 0.92. What is the ratio of the Economic output (BoP, current US$) in Denmark in 2010 to that in 2011?
Your answer should be compact. 0.89. What is the ratio of the Economic output (BoP, current US$) of Montenegro in 2010 to that in 2011?
Your response must be concise. 1.01. What is the ratio of the Economic output (BoP, current US$) in Europe(developing only) in 2010 to that in 2012?
Your answer should be compact. 0.86. What is the ratio of the Economic output (BoP, current US$) of Denmark in 2010 to that in 2012?
Your answer should be very brief. 0.9. What is the ratio of the Economic output (BoP, current US$) of Europe(developing only) in 2010 to that in 2013?
Ensure brevity in your answer.  0.77. What is the ratio of the Economic output (BoP, current US$) in Denmark in 2010 to that in 2013?
Provide a succinct answer. 0.83. What is the ratio of the Economic output (BoP, current US$) in Europe(developing only) in 2010 to that in 2014?
Your answer should be very brief. 0.75. What is the ratio of the Economic output (BoP, current US$) in Denmark in 2010 to that in 2014?
Offer a terse response. 0.81. What is the ratio of the Economic output (BoP, current US$) of Montenegro in 2010 to that in 2014?
Ensure brevity in your answer.  1. What is the ratio of the Economic output (BoP, current US$) of Europe(developing only) in 2011 to that in 2012?
Make the answer very short. 0.94. What is the ratio of the Economic output (BoP, current US$) of Montenegro in 2011 to that in 2012?
Your answer should be compact. 1. What is the ratio of the Economic output (BoP, current US$) of Europe(developing only) in 2011 to that in 2013?
Ensure brevity in your answer.  0.84. What is the ratio of the Economic output (BoP, current US$) of Denmark in 2011 to that in 2013?
Your response must be concise. 0.93. What is the ratio of the Economic output (BoP, current US$) of Montenegro in 2011 to that in 2013?
Your answer should be very brief. 0.99. What is the ratio of the Economic output (BoP, current US$) in Europe(developing only) in 2011 to that in 2014?
Your response must be concise. 0.82. What is the ratio of the Economic output (BoP, current US$) of Denmark in 2011 to that in 2014?
Make the answer very short. 0.91. What is the ratio of the Economic output (BoP, current US$) in Europe(developing only) in 2012 to that in 2013?
Your response must be concise. 0.9. What is the ratio of the Economic output (BoP, current US$) in Denmark in 2012 to that in 2013?
Your response must be concise. 0.92. What is the ratio of the Economic output (BoP, current US$) in Montenegro in 2012 to that in 2013?
Make the answer very short. 0.99. What is the ratio of the Economic output (BoP, current US$) of Europe(developing only) in 2012 to that in 2014?
Your answer should be compact. 0.87. What is the ratio of the Economic output (BoP, current US$) in Denmark in 2012 to that in 2014?
Offer a very short reply. 0.91. What is the ratio of the Economic output (BoP, current US$) in Europe(developing only) in 2013 to that in 2014?
Ensure brevity in your answer.  0.97. What is the ratio of the Economic output (BoP, current US$) in Denmark in 2013 to that in 2014?
Your answer should be very brief. 0.98. What is the ratio of the Economic output (BoP, current US$) of Montenegro in 2013 to that in 2014?
Offer a very short reply. 1.01. What is the difference between the highest and the second highest Economic output (BoP, current US$) of Europe(developing only)?
Your response must be concise. 3.02e+09. What is the difference between the highest and the second highest Economic output (BoP, current US$) in Denmark?
Provide a succinct answer. 9.70e+08. What is the difference between the highest and the second highest Economic output (BoP, current US$) of Montenegro?
Offer a terse response. 1.42e+08. What is the difference between the highest and the lowest Economic output (BoP, current US$) of Europe(developing only)?
Offer a terse response. 3.03e+1. What is the difference between the highest and the lowest Economic output (BoP, current US$) in Denmark?
Your answer should be very brief. 1.19e+1. What is the difference between the highest and the lowest Economic output (BoP, current US$) in Montenegro?
Provide a short and direct response. 2.15e+08. 